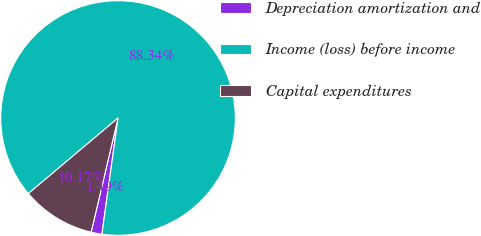Convert chart to OTSL. <chart><loc_0><loc_0><loc_500><loc_500><pie_chart><fcel>Depreciation amortization and<fcel>Income (loss) before income<fcel>Capital expenditures<nl><fcel>1.49%<fcel>88.34%<fcel>10.17%<nl></chart> 